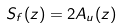<formula> <loc_0><loc_0><loc_500><loc_500>S _ { f } ( z ) = 2 A _ { u } ( z )</formula> 